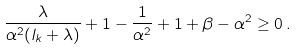Convert formula to latex. <formula><loc_0><loc_0><loc_500><loc_500>\frac { \lambda } { \alpha ^ { 2 } ( l _ { k } + \lambda ) } + 1 - \frac { 1 } { \alpha ^ { 2 } } + 1 + \beta - \alpha ^ { 2 } \geq 0 \, .</formula> 